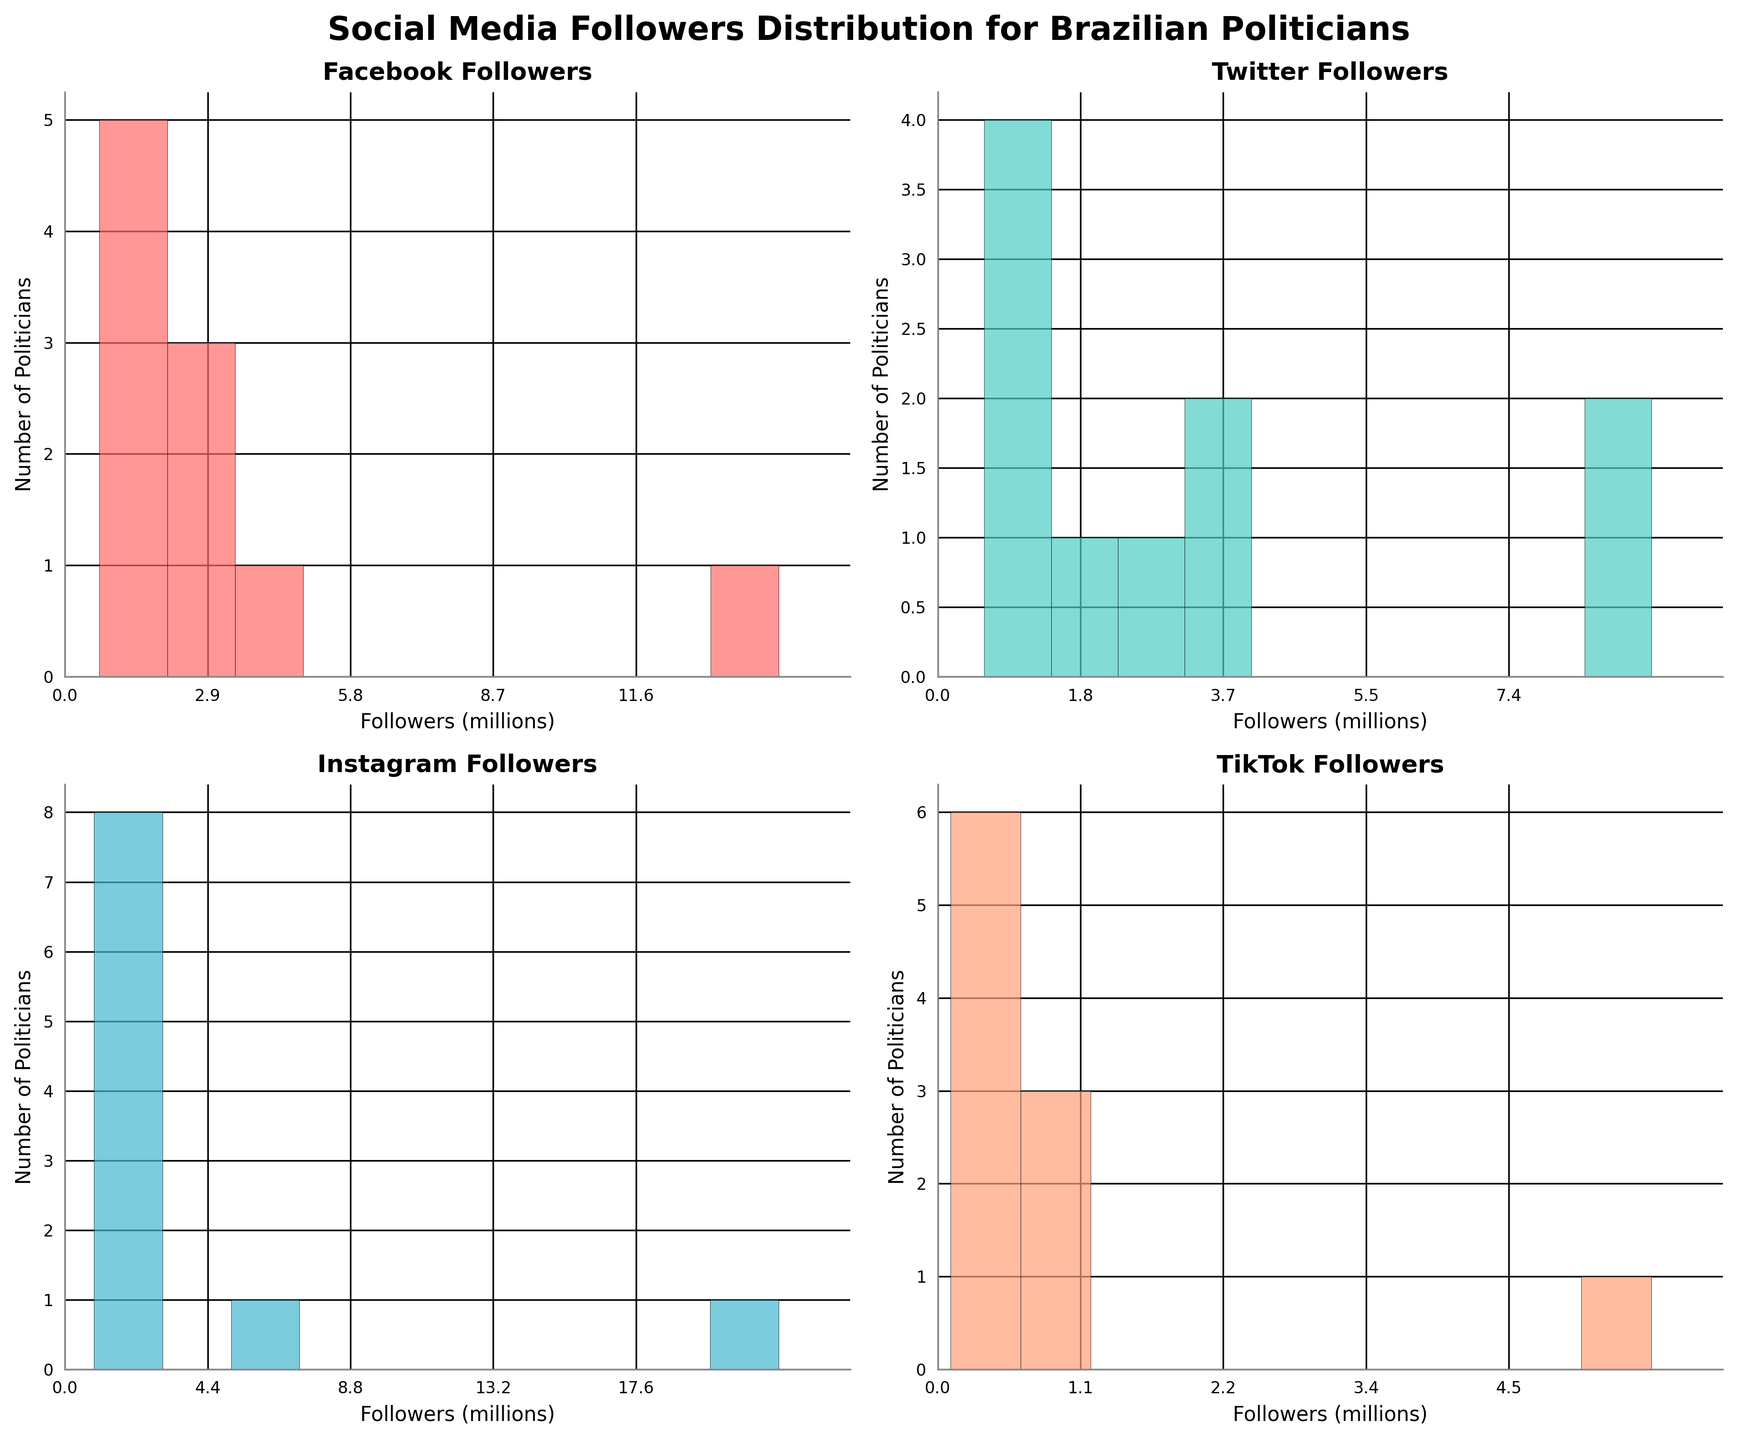What is the title of the figure? The title is usually found at the top of the figure. In this case, it provides the main theme or topic of the plots.
Answer: Social Media Followers Distribution for Brazilian Politicians How many platforms are analyzed in the figure? The number of platforms can be inferred by counting the number of subplots, each representing a different social media platform.
Answer: Four Which social media platform has the highest maximum followers among Brazilian politicians? To find this, look at the histogram with the highest maximum value on the x-axis. Compare the end of the x-axis across all subplots.
Answer: Instagram What's the range of Facebook followers in millions? The range can be derived from the x-axis of the Facebook Followers subplot by noting the minimum and maximum values.
Answer: 0 to 14.5 million How many politicians have between 0 and 4 million followers on Twitter? Count the number of bars (bins) in the histogram of Twitter Followers that fall within the 0 to 4 million x-axis range.
Answer: Nine What is the difference in maximum number of followers between TikTok and Twitter? Identify the maximum followers in TikTok and Twitter histograms, then subtract the two values.
Answer: 4.4 million (5.6 - 1.2) Which platform has the most politicians with fewer than 1 million followers? Compare the bins representing fewer than 1 million followers across all histograms and identify the platform with the highest count.
Answer: TikTok Do more politicians have between 2 and 4 million followers on Facebook or Instagram? Compare the number of bars within the 2 to 4 million range between the Facebook and Instagram histograms.
Answer: Facebook How does the follower distribution on TikTok compare to the distribution on Instagram? Examine the histograms for TikTok and Instagram to compare the spread and concentration of follower counts.
Answer: TikTok follower distribution is skewed towards fewer followers, whereas Instagram has a broader spread with higher maximum values Which politician has the highest total number of followers across all platforms? Add the followers for each politician across all platforms and compare the sums.
Answer: Jair Bolsonaro 